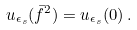Convert formula to latex. <formula><loc_0><loc_0><loc_500><loc_500>u _ { \epsilon _ { s } } ( { \bar { f } } ^ { 2 } ) = u _ { \epsilon _ { s } } ( 0 ) \, .</formula> 